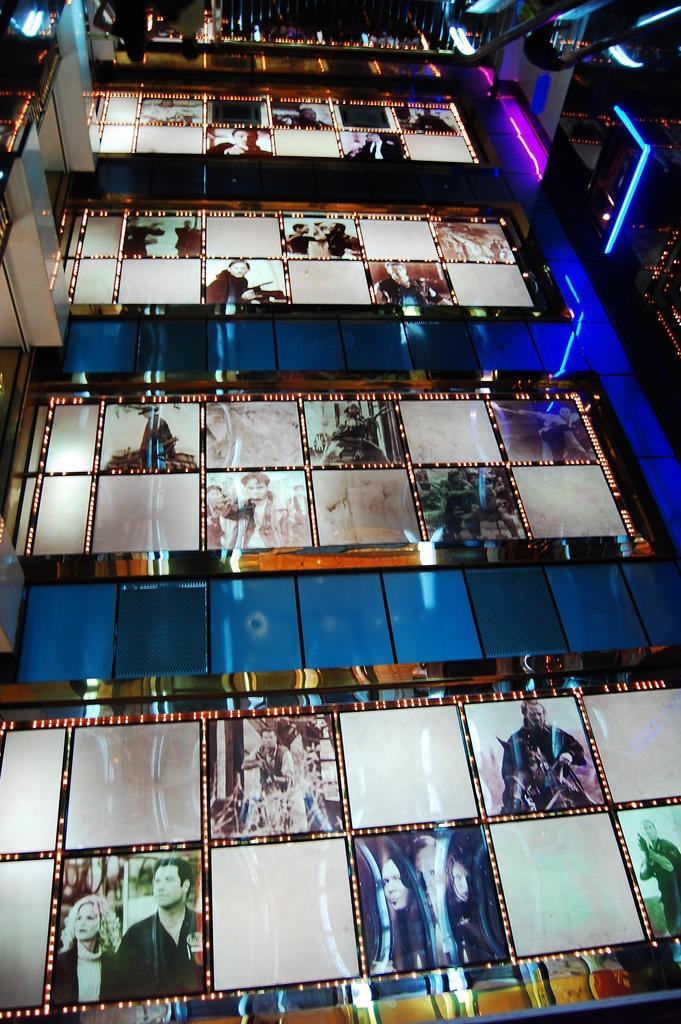How would you summarize this image in a sentence or two? In this image I can see number of photos in the center of this image and I see the lights on the top of this image. 